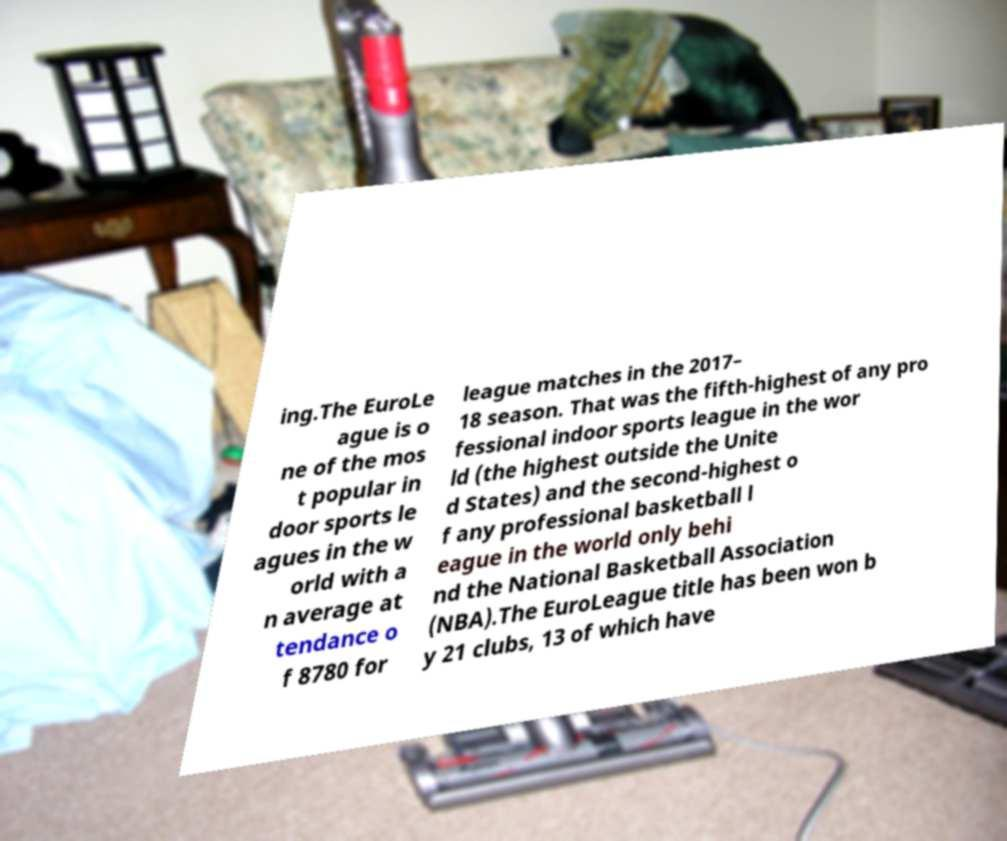Can you read and provide the text displayed in the image?This photo seems to have some interesting text. Can you extract and type it out for me? ing.The EuroLe ague is o ne of the mos t popular in door sports le agues in the w orld with a n average at tendance o f 8780 for league matches in the 2017– 18 season. That was the fifth-highest of any pro fessional indoor sports league in the wor ld (the highest outside the Unite d States) and the second-highest o f any professional basketball l eague in the world only behi nd the National Basketball Association (NBA).The EuroLeague title has been won b y 21 clubs, 13 of which have 